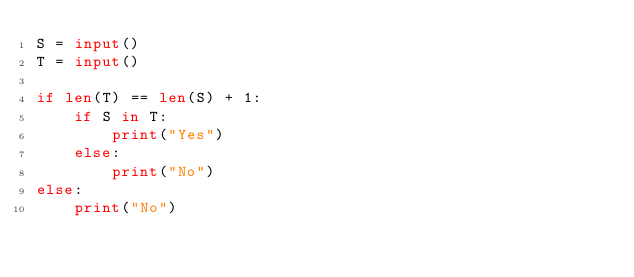<code> <loc_0><loc_0><loc_500><loc_500><_Python_>S = input()
T = input()

if len(T) == len(S) + 1:
    if S in T:
        print("Yes")
    else:
        print("No")  
else:
    print("No")

</code> 